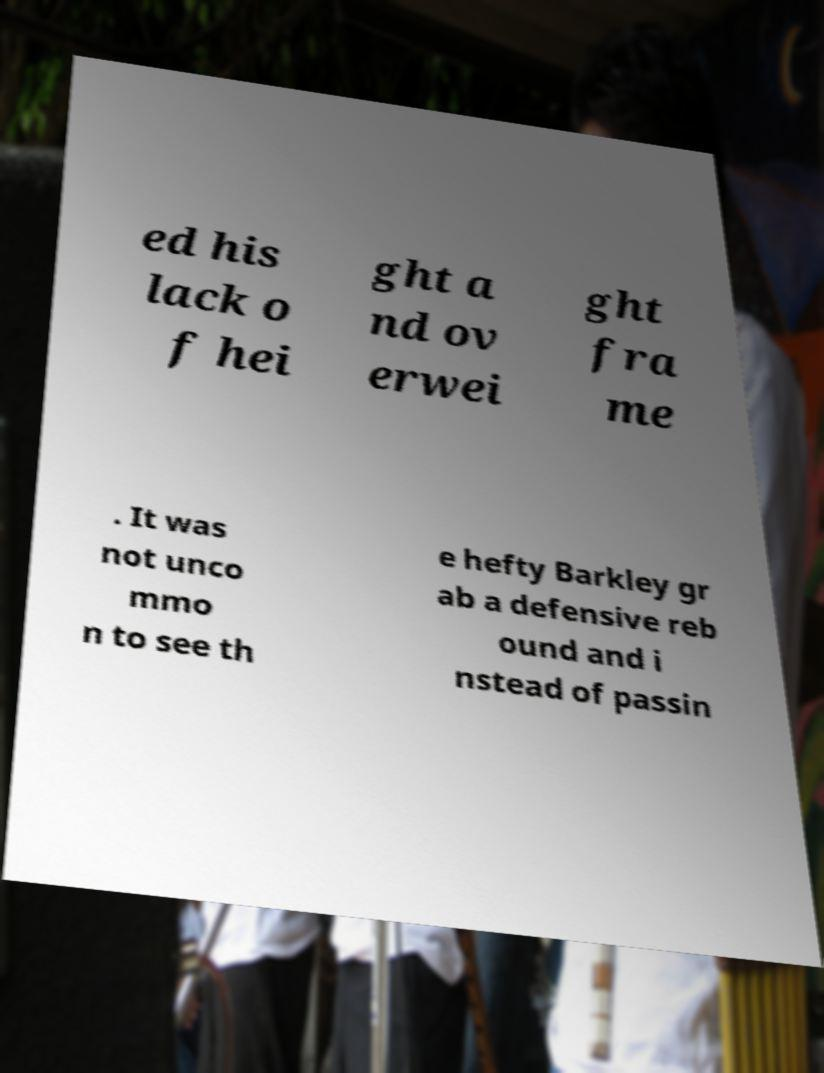Please read and relay the text visible in this image. What does it say? ed his lack o f hei ght a nd ov erwei ght fra me . It was not unco mmo n to see th e hefty Barkley gr ab a defensive reb ound and i nstead of passin 